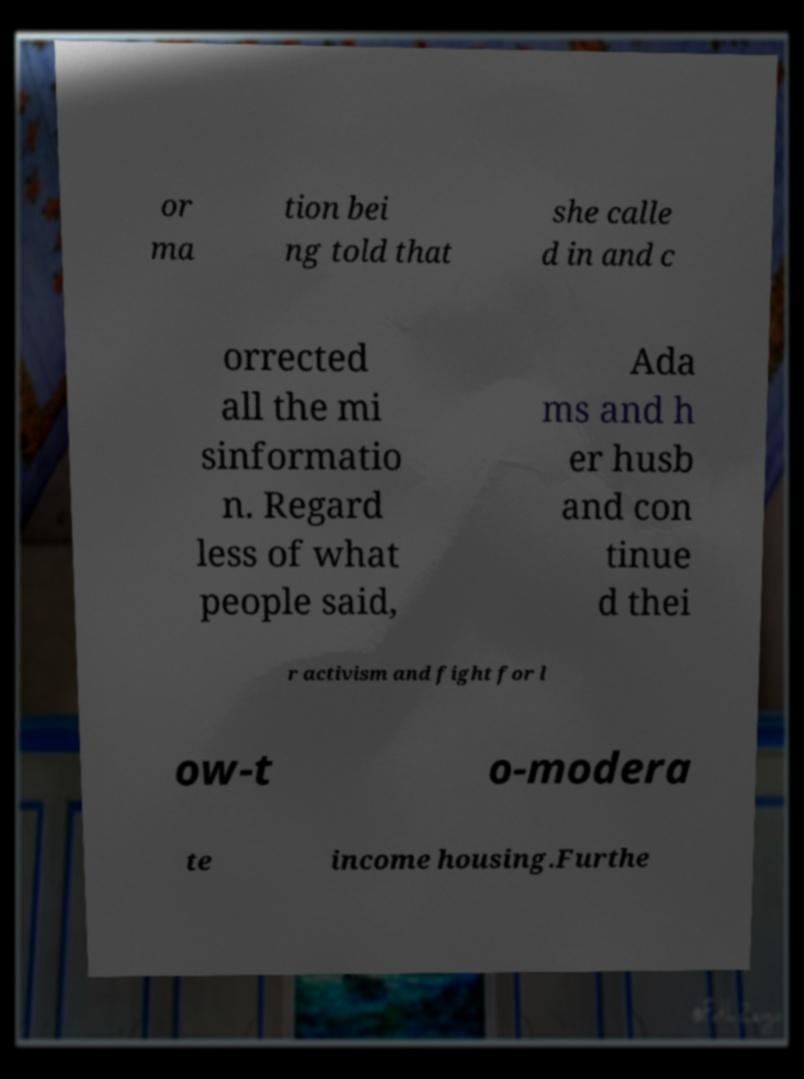Please read and relay the text visible in this image. What does it say? or ma tion bei ng told that she calle d in and c orrected all the mi sinformatio n. Regard less of what people said, Ada ms and h er husb and con tinue d thei r activism and fight for l ow-t o-modera te income housing.Furthe 